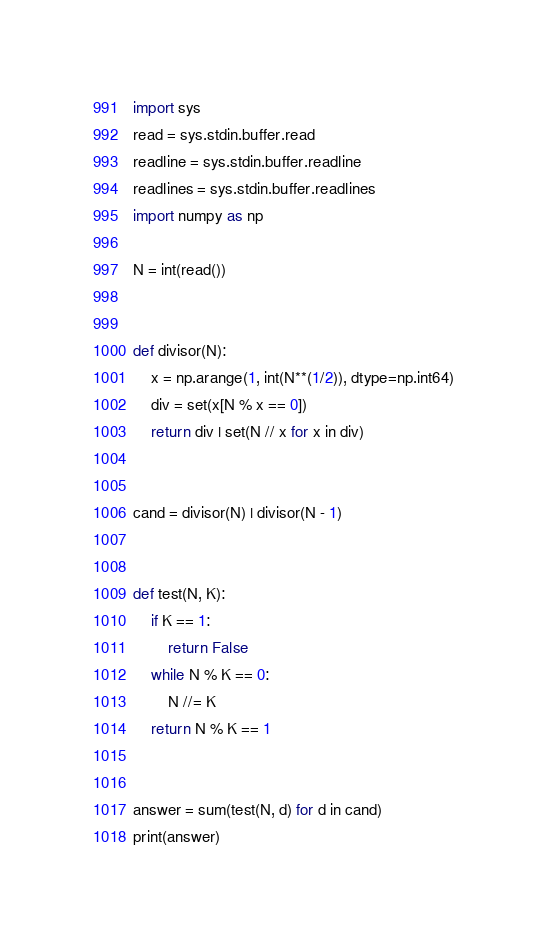Convert code to text. <code><loc_0><loc_0><loc_500><loc_500><_Python_>import sys
read = sys.stdin.buffer.read
readline = sys.stdin.buffer.readline
readlines = sys.stdin.buffer.readlines
import numpy as np
 
N = int(read())
 
 
def divisor(N):
    x = np.arange(1, int(N**(1/2)), dtype=np.int64)
    div = set(x[N % x == 0])
    return div | set(N // x for x in div)
 
 
cand = divisor(N) | divisor(N - 1)
 
 
def test(N, K):
    if K == 1:
        return False
    while N % K == 0:
        N //= K
    return N % K == 1
 
 
answer = sum(test(N, d) for d in cand)
print(answer)</code> 